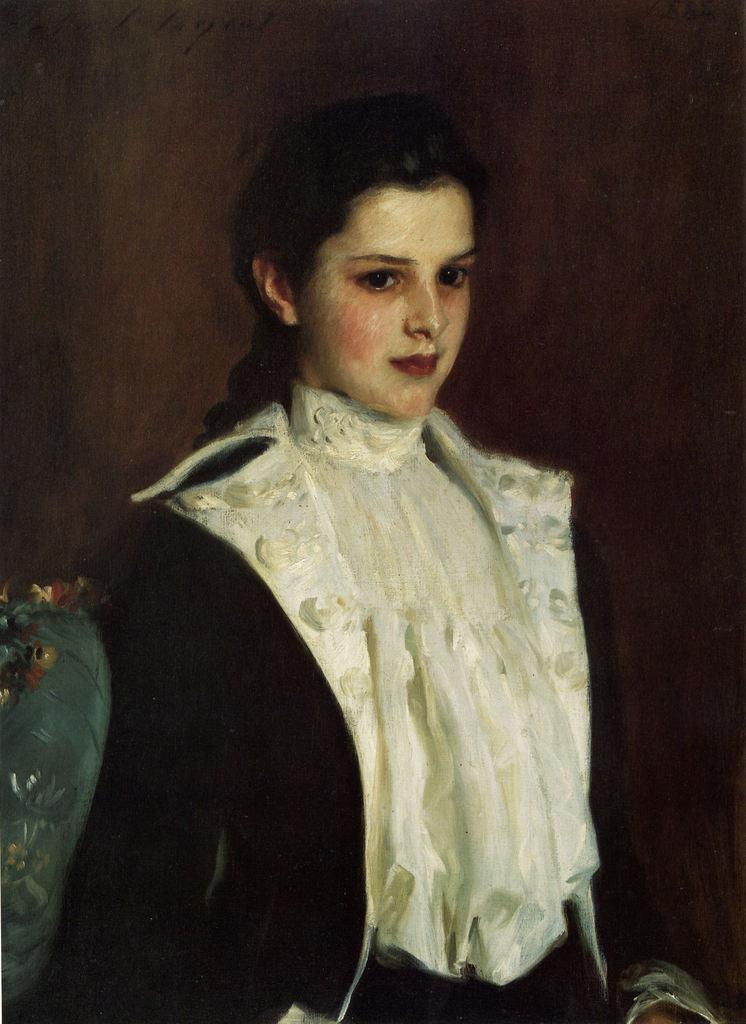What is the main subject of the image? There is a beautiful woman in the image. What is the woman doing in the image? The woman is standing. What is the woman wearing in the image? The woman is wearing a white dress and a black coat. What type of rod can be seen in the woman's hand in the image? There is no rod present in the woman's hand or in the image. 